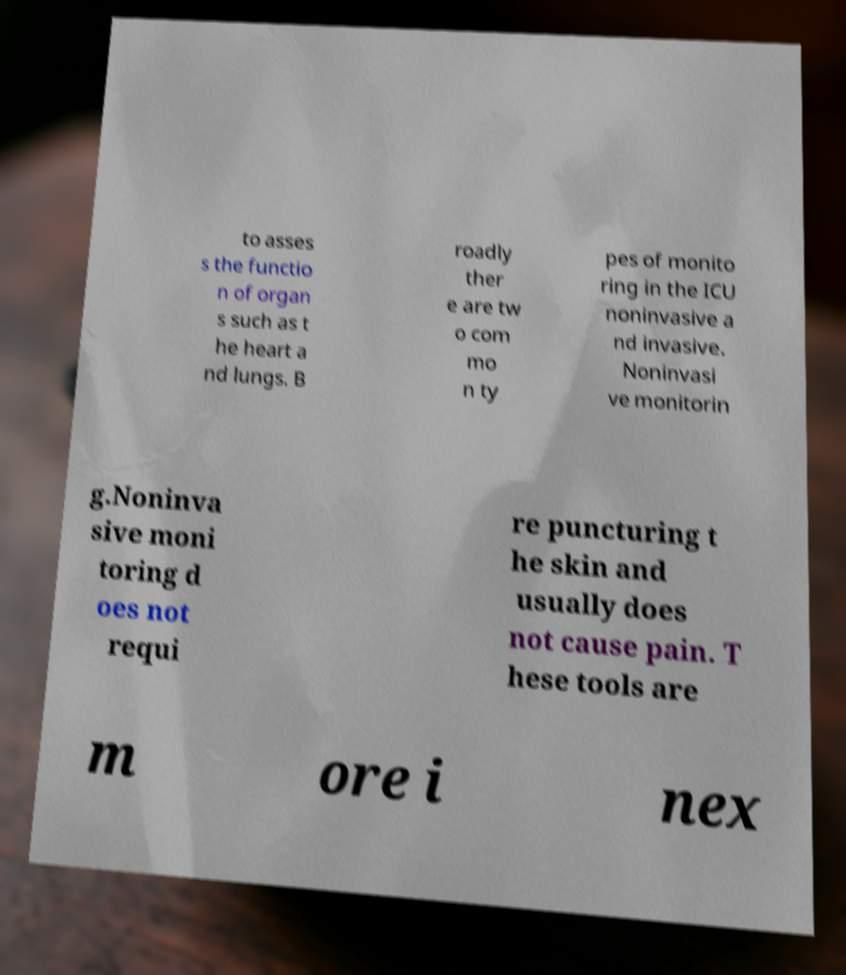Could you assist in decoding the text presented in this image and type it out clearly? to asses s the functio n of organ s such as t he heart a nd lungs. B roadly ther e are tw o com mo n ty pes of monito ring in the ICU noninvasive a nd invasive. Noninvasi ve monitorin g.Noninva sive moni toring d oes not requi re puncturing t he skin and usually does not cause pain. T hese tools are m ore i nex 